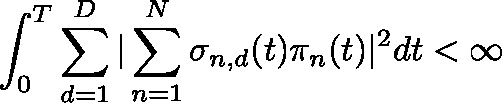Convert formula to latex. <formula><loc_0><loc_0><loc_500><loc_500>\int _ { 0 } ^ { T } \sum _ { d = 1 } ^ { D } | \sum _ { n = 1 } ^ { N } \sigma _ { n , d } ( t ) \pi _ { n } ( t ) | ^ { 2 } d t < \infty</formula> 